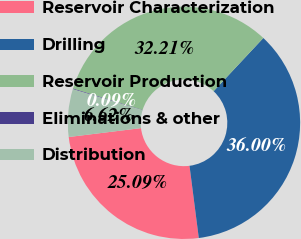Convert chart. <chart><loc_0><loc_0><loc_500><loc_500><pie_chart><fcel>Reservoir Characterization<fcel>Drilling<fcel>Reservoir Production<fcel>Eliminations & other<fcel>Distribution<nl><fcel>25.09%<fcel>36.0%<fcel>32.21%<fcel>0.09%<fcel>6.62%<nl></chart> 